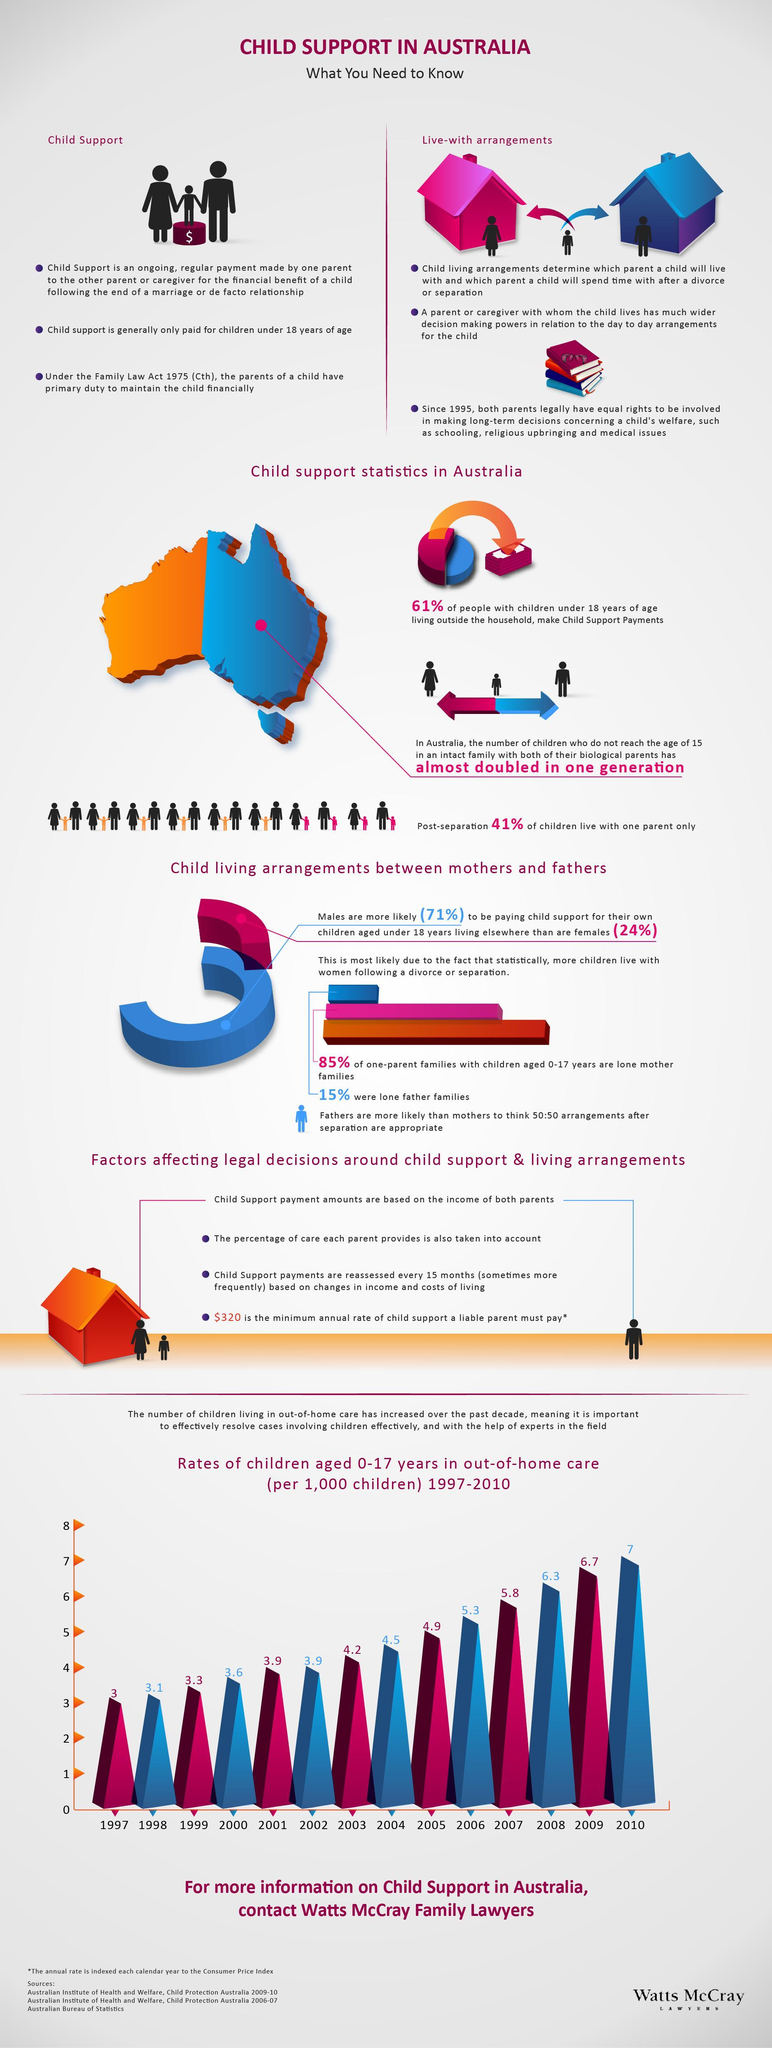What percentage of people living outside the household do not make child support payments?
Answer the question with a short phrase. 39% What is the percentage increase in the rate of children in out of home care from 1997 to 2010? 4% 